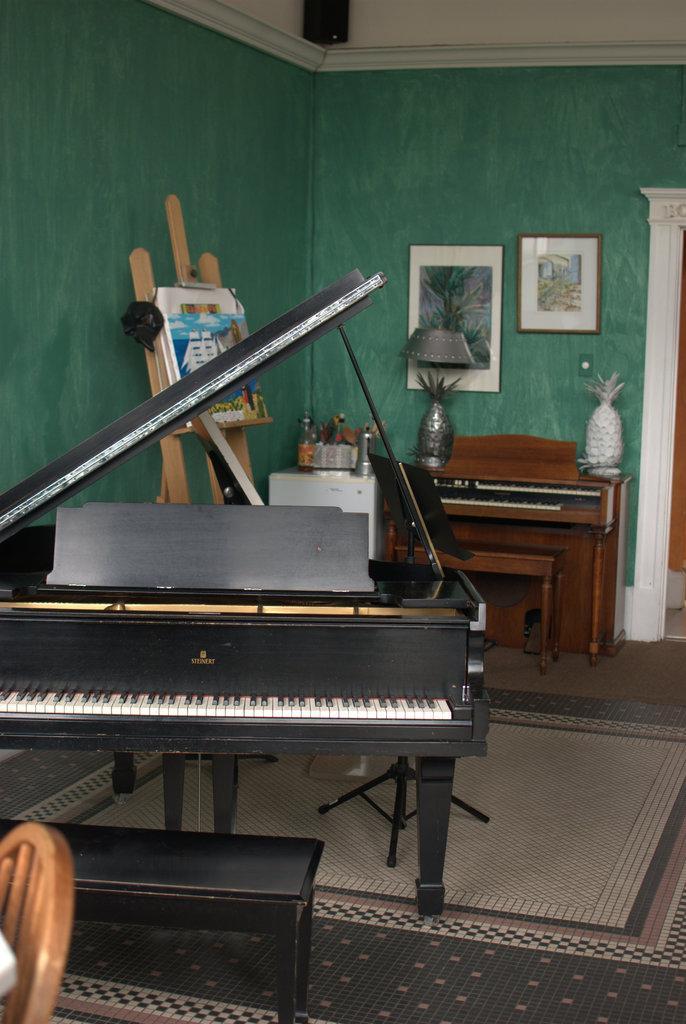Could you give a brief overview of what you see in this image? It's a musical instrument in the middle of an image there is a lamp,photos behind that wall. 